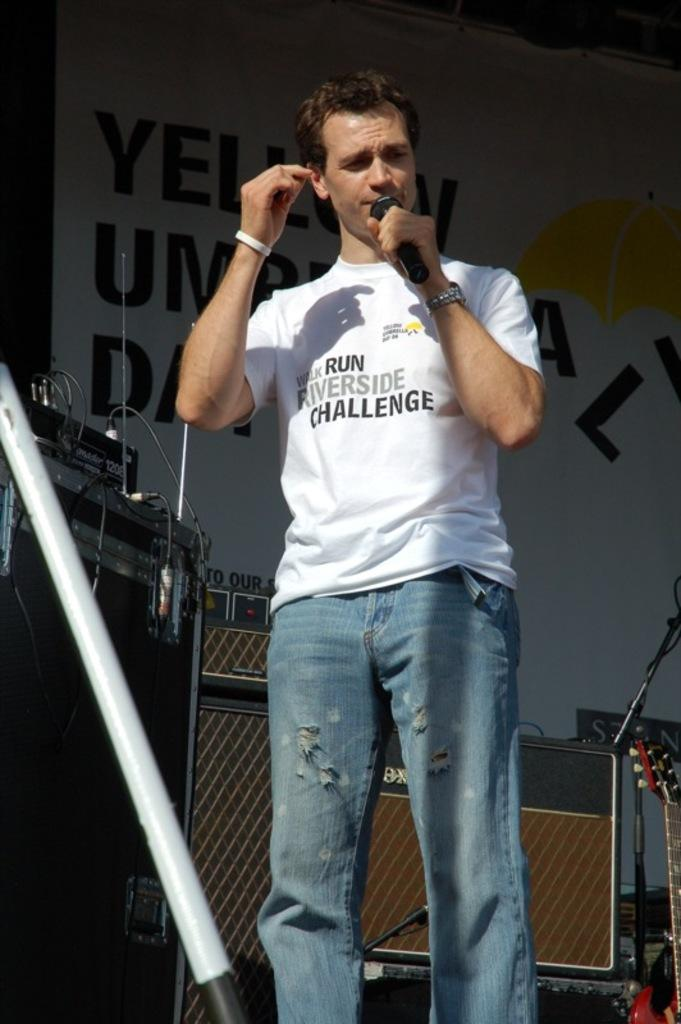Who is present in the image? There is a man in the image. What is the man doing in the image? The man is standing in the image. What object is the man holding in the image? The man is holding a microphone in the image. What else can be seen in the image besides the man? There are musical instruments and a banner in the image. What type of cow can be seen grazing in the background of the image? There is no cow present in the image; it features a man holding a microphone, musical instruments, and a banner. 